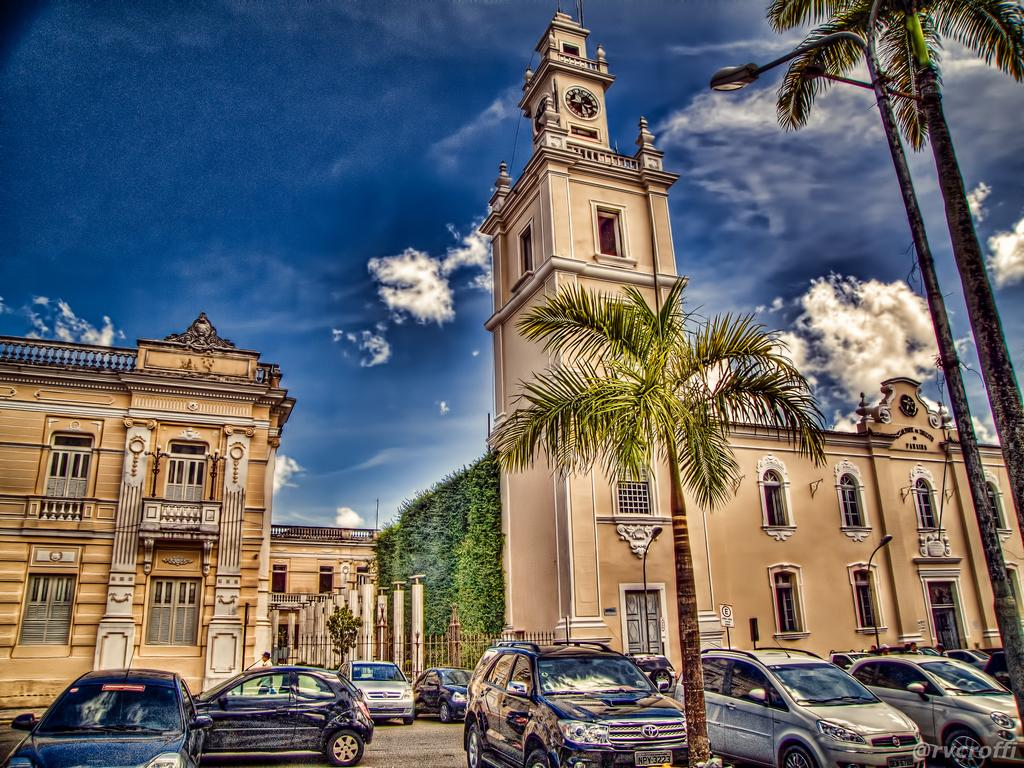What type of structures can be seen in the image? There are buildings in the image. What other natural elements are present in the image? There are trees in the image. What type of artificial lighting is visible in the image? There are street lights in the image. What type of vehicles are parked near the buildings? There are cars parked near the buildings. What can be seen in the background of the image? The sky is visible in the background of the image, and there are clouds in the sky. How does the scale of the buildings change throughout the image? The scale of the buildings does not change throughout the image; they appear to be the same size. What type of balloon can be seen floating in the sky in the image? There is no balloon present in the image; only buildings, trees, street lights, cars, and clouds are visible. 